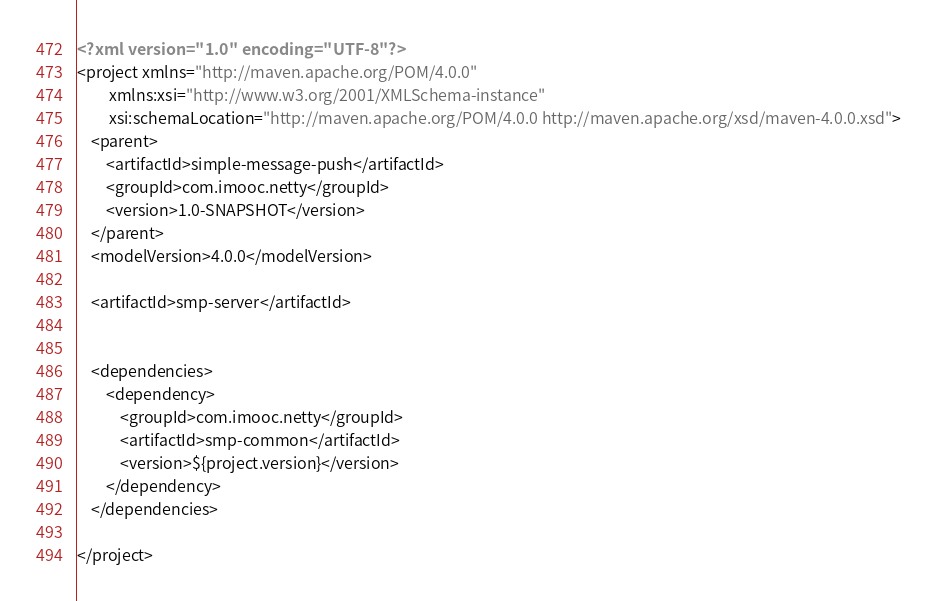Convert code to text. <code><loc_0><loc_0><loc_500><loc_500><_XML_><?xml version="1.0" encoding="UTF-8"?>
<project xmlns="http://maven.apache.org/POM/4.0.0"
         xmlns:xsi="http://www.w3.org/2001/XMLSchema-instance"
         xsi:schemaLocation="http://maven.apache.org/POM/4.0.0 http://maven.apache.org/xsd/maven-4.0.0.xsd">
    <parent>
        <artifactId>simple-message-push</artifactId>
        <groupId>com.imooc.netty</groupId>
        <version>1.0-SNAPSHOT</version>
    </parent>
    <modelVersion>4.0.0</modelVersion>

    <artifactId>smp-server</artifactId>


    <dependencies>
        <dependency>
            <groupId>com.imooc.netty</groupId>
            <artifactId>smp-common</artifactId>
            <version>${project.version}</version>
        </dependency>
    </dependencies>

</project></code> 